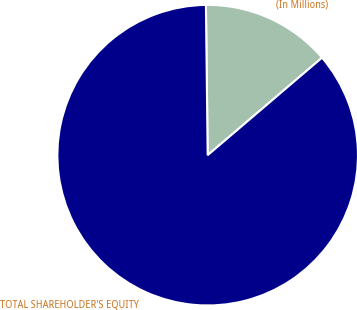Convert chart. <chart><loc_0><loc_0><loc_500><loc_500><pie_chart><fcel>(In Millions)<fcel>TOTAL SHAREHOLDER'S EQUITY<nl><fcel>13.95%<fcel>86.05%<nl></chart> 